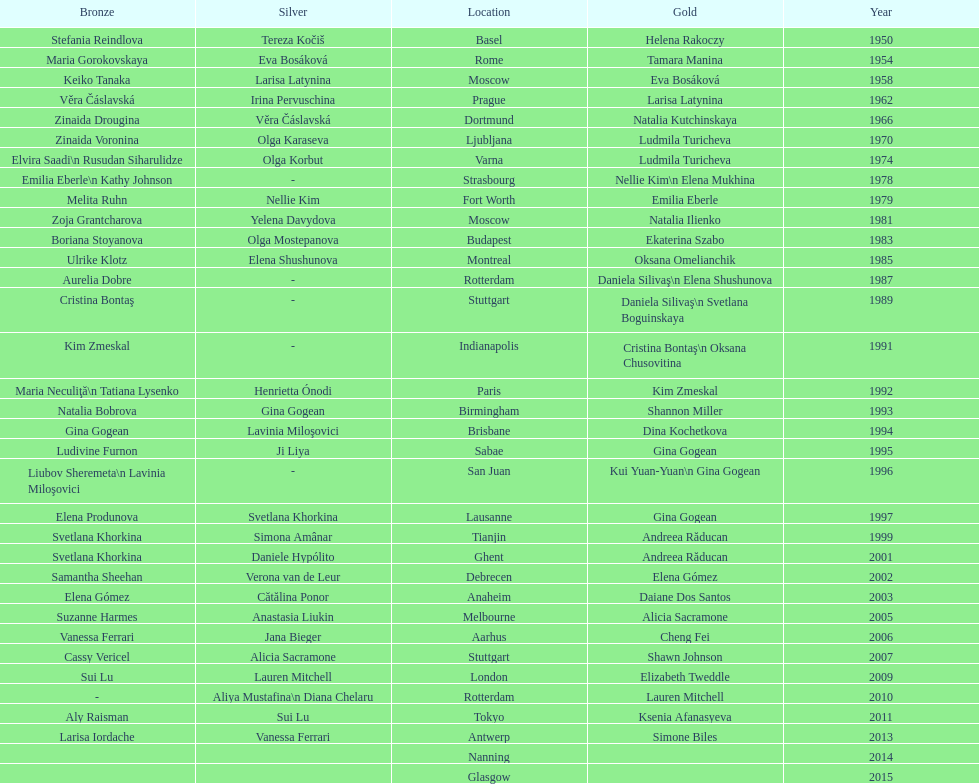What is the total number of russian gymnasts that have won silver. 8. 